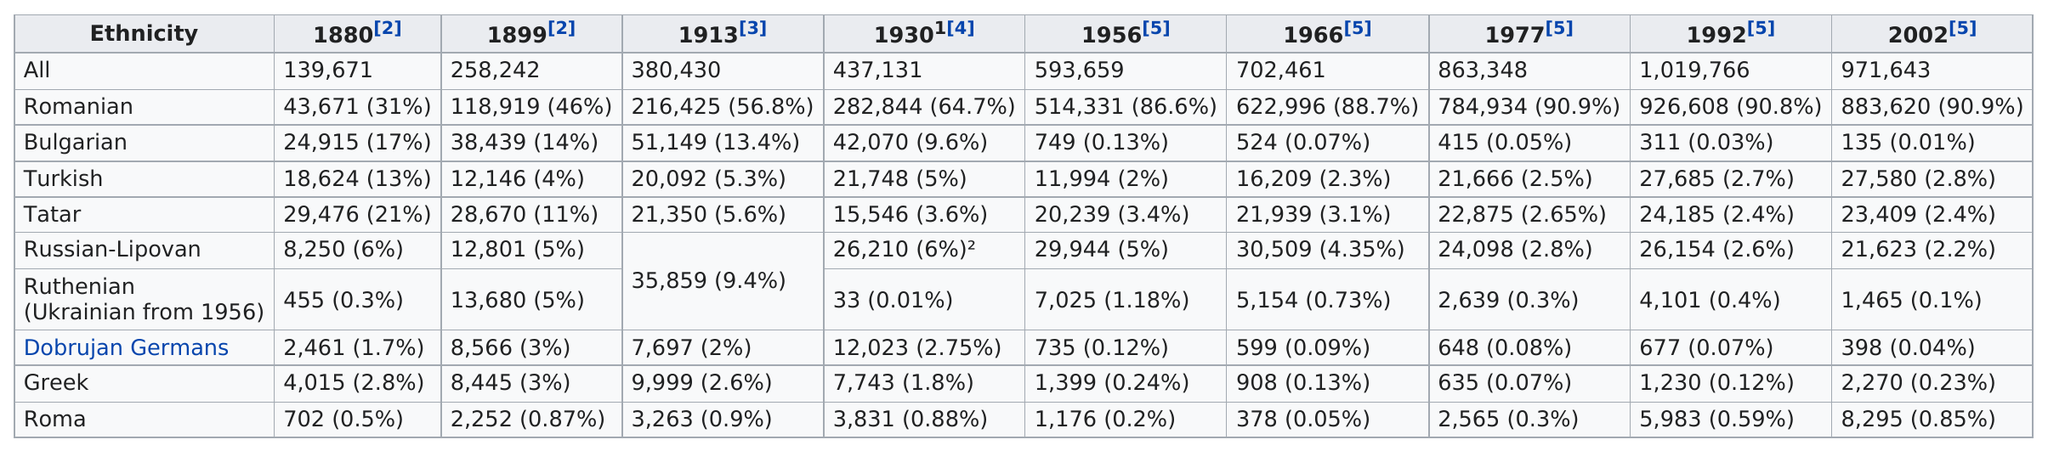Identify some key points in this picture. There were 30,509 Russian-Lipovans in 1966. In 1992, the Romanian ethnicity had the largest population among all the ethnicities. In 1930, the most common ethnicity besides Romanian was Bulgarian. The population in Northern Dobruja was recorded to be the highest in the year 1992. 